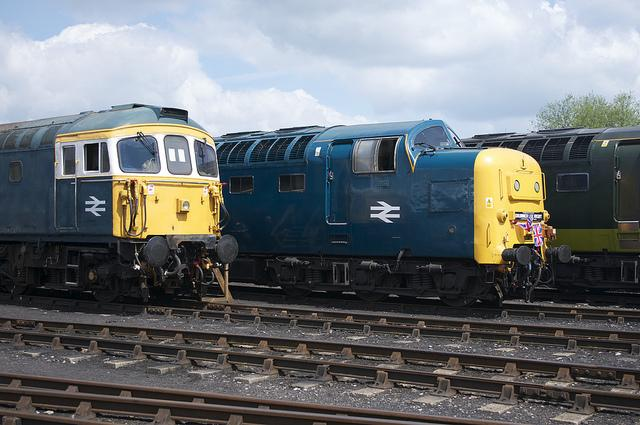The front of the vehicle is mostly the color of what? yellow 